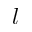Convert formula to latex. <formula><loc_0><loc_0><loc_500><loc_500>l</formula> 